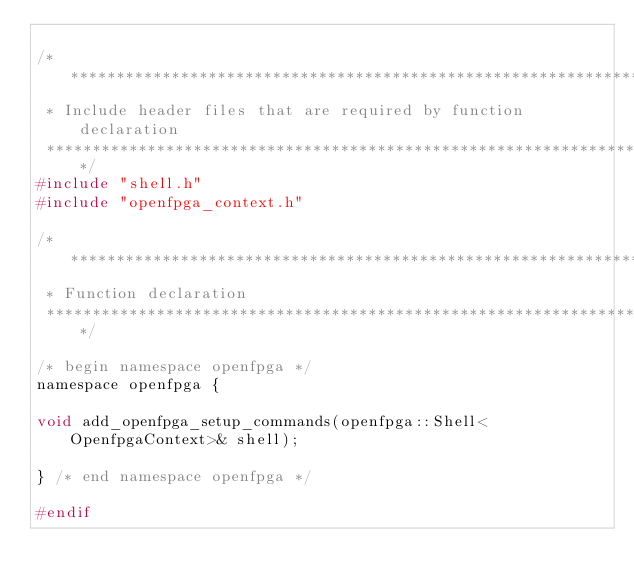<code> <loc_0><loc_0><loc_500><loc_500><_C_>
/********************************************************************
 * Include header files that are required by function declaration
 *******************************************************************/
#include "shell.h"
#include "openfpga_context.h"

/********************************************************************
 * Function declaration
 *******************************************************************/

/* begin namespace openfpga */
namespace openfpga {

void add_openfpga_setup_commands(openfpga::Shell<OpenfpgaContext>& shell); 

} /* end namespace openfpga */

#endif
</code> 